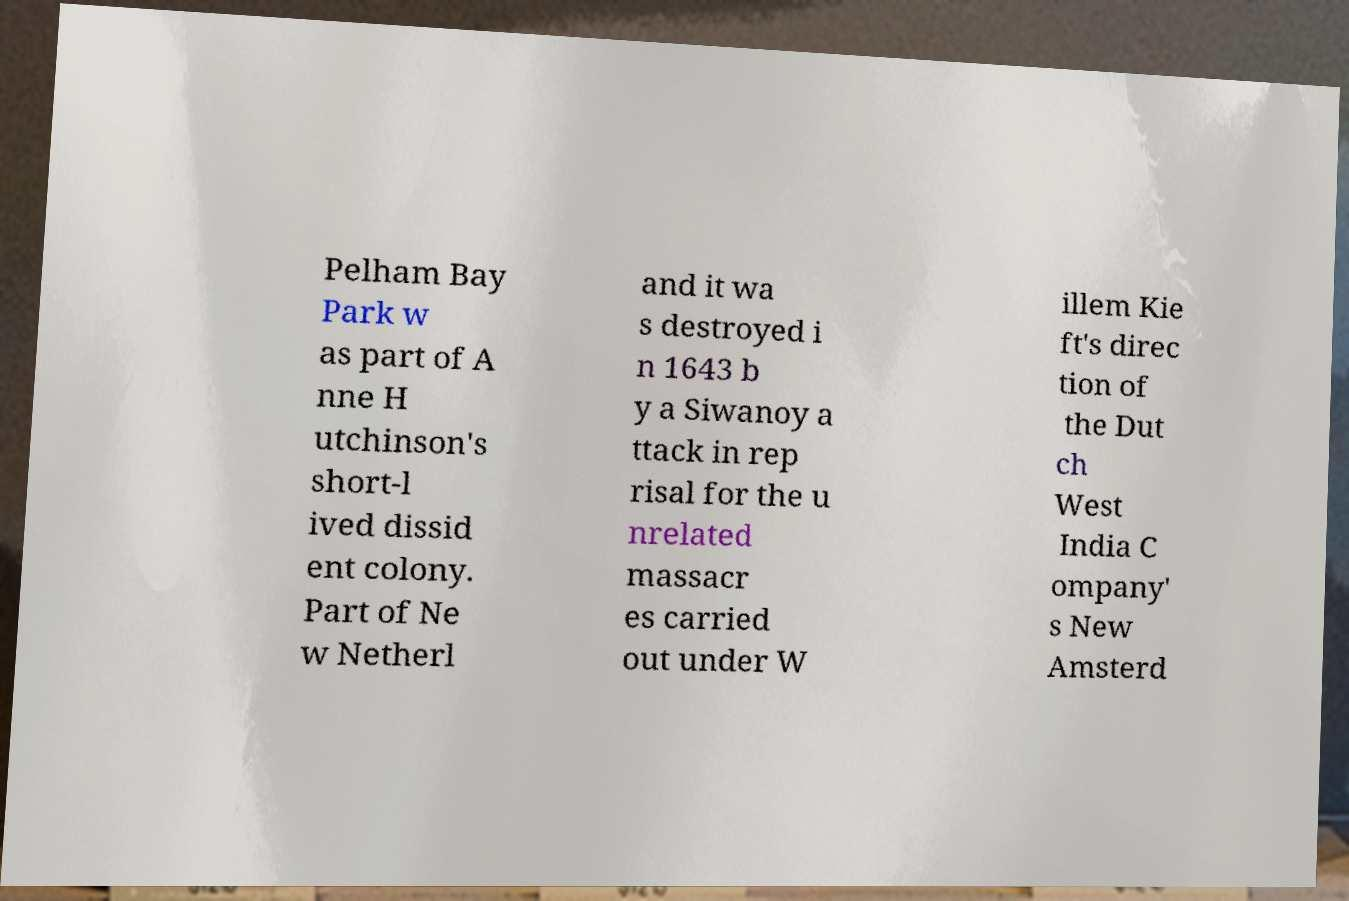Could you assist in decoding the text presented in this image and type it out clearly? Pelham Bay Park w as part of A nne H utchinson's short-l ived dissid ent colony. Part of Ne w Netherl and it wa s destroyed i n 1643 b y a Siwanoy a ttack in rep risal for the u nrelated massacr es carried out under W illem Kie ft's direc tion of the Dut ch West India C ompany' s New Amsterd 